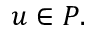Convert formula to latex. <formula><loc_0><loc_0><loc_500><loc_500>u \in P .</formula> 